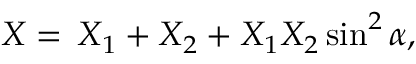<formula> <loc_0><loc_0><loc_500><loc_500>X = \, X _ { 1 } + X _ { 2 } + X _ { 1 } X _ { 2 } \sin ^ { 2 } \alpha ,</formula> 